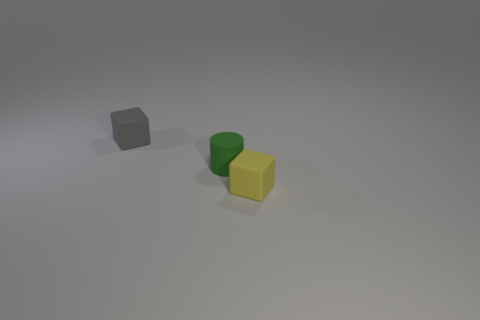Add 1 small green rubber things. How many objects exist? 4 Subtract all cubes. How many objects are left? 1 Subtract all yellow objects. Subtract all blue matte blocks. How many objects are left? 2 Add 1 small green matte things. How many small green matte things are left? 2 Add 2 large brown rubber things. How many large brown rubber things exist? 2 Subtract 0 brown balls. How many objects are left? 3 